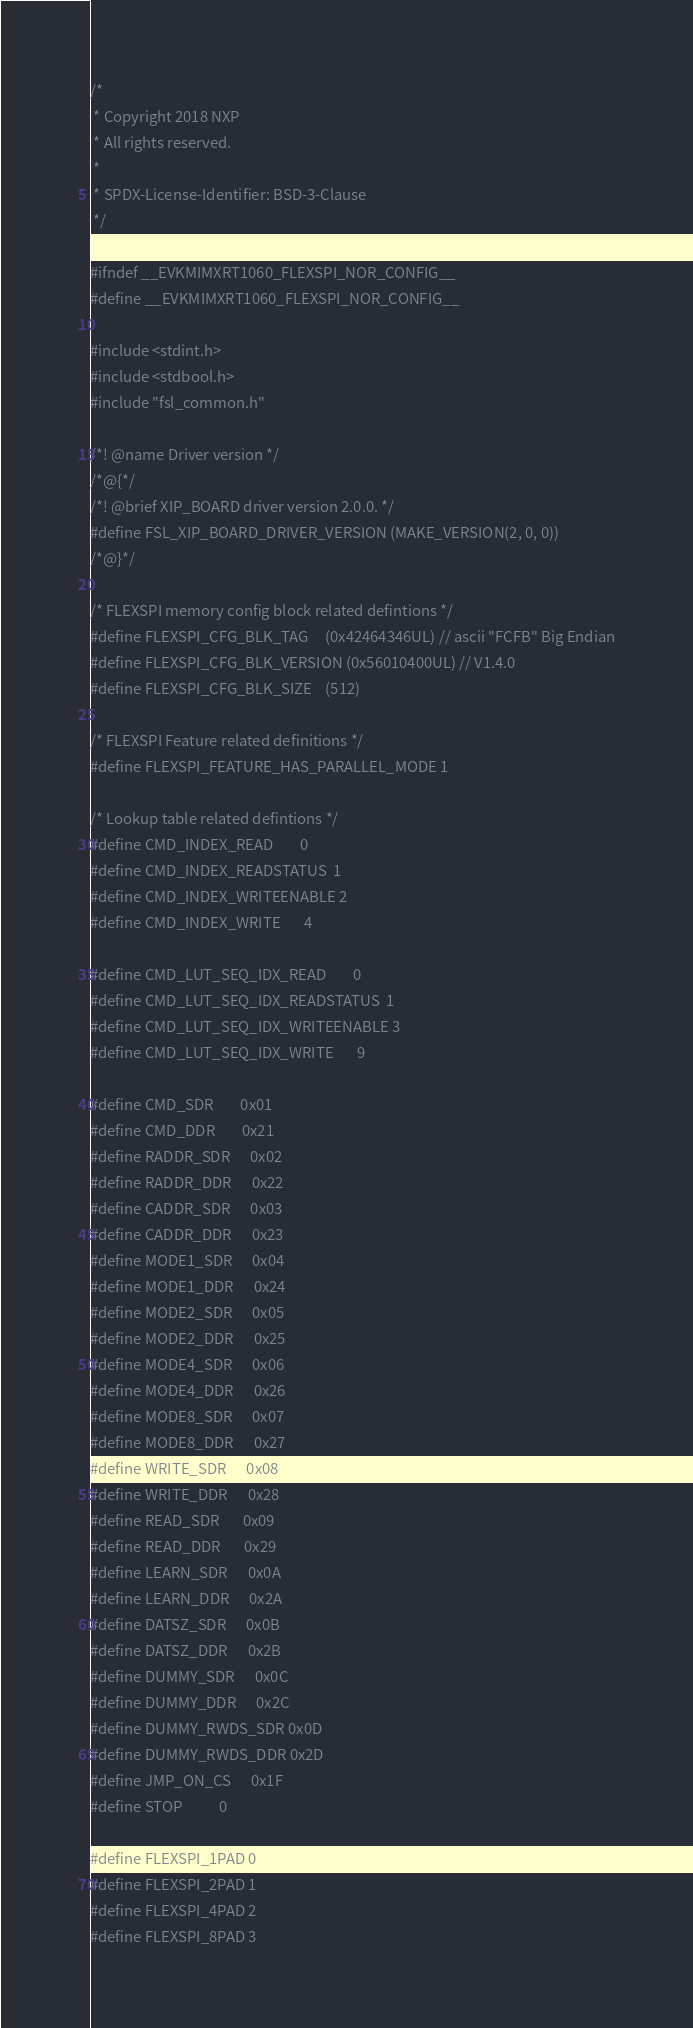Convert code to text. <code><loc_0><loc_0><loc_500><loc_500><_C_>/*
 * Copyright 2018 NXP
 * All rights reserved.
 *
 * SPDX-License-Identifier: BSD-3-Clause
 */

#ifndef __EVKMIMXRT1060_FLEXSPI_NOR_CONFIG__
#define __EVKMIMXRT1060_FLEXSPI_NOR_CONFIG__

#include <stdint.h>
#include <stdbool.h>
#include "fsl_common.h"

/*! @name Driver version */
/*@{*/
/*! @brief XIP_BOARD driver version 2.0.0. */
#define FSL_XIP_BOARD_DRIVER_VERSION (MAKE_VERSION(2, 0, 0))
/*@}*/

/* FLEXSPI memory config block related defintions */
#define FLEXSPI_CFG_BLK_TAG     (0x42464346UL) // ascii "FCFB" Big Endian
#define FLEXSPI_CFG_BLK_VERSION (0x56010400UL) // V1.4.0
#define FLEXSPI_CFG_BLK_SIZE    (512)

/* FLEXSPI Feature related definitions */
#define FLEXSPI_FEATURE_HAS_PARALLEL_MODE 1

/* Lookup table related defintions */
#define CMD_INDEX_READ        0
#define CMD_INDEX_READSTATUS  1
#define CMD_INDEX_WRITEENABLE 2
#define CMD_INDEX_WRITE       4

#define CMD_LUT_SEQ_IDX_READ        0
#define CMD_LUT_SEQ_IDX_READSTATUS  1
#define CMD_LUT_SEQ_IDX_WRITEENABLE 3
#define CMD_LUT_SEQ_IDX_WRITE       9

#define CMD_SDR        0x01
#define CMD_DDR        0x21
#define RADDR_SDR      0x02
#define RADDR_DDR      0x22
#define CADDR_SDR      0x03
#define CADDR_DDR      0x23
#define MODE1_SDR      0x04
#define MODE1_DDR      0x24
#define MODE2_SDR      0x05
#define MODE2_DDR      0x25
#define MODE4_SDR      0x06
#define MODE4_DDR      0x26
#define MODE8_SDR      0x07
#define MODE8_DDR      0x27
#define WRITE_SDR      0x08
#define WRITE_DDR      0x28
#define READ_SDR       0x09
#define READ_DDR       0x29
#define LEARN_SDR      0x0A
#define LEARN_DDR      0x2A
#define DATSZ_SDR      0x0B
#define DATSZ_DDR      0x2B
#define DUMMY_SDR      0x0C
#define DUMMY_DDR      0x2C
#define DUMMY_RWDS_SDR 0x0D
#define DUMMY_RWDS_DDR 0x2D
#define JMP_ON_CS      0x1F
#define STOP           0

#define FLEXSPI_1PAD 0
#define FLEXSPI_2PAD 1
#define FLEXSPI_4PAD 2
#define FLEXSPI_8PAD 3
</code> 